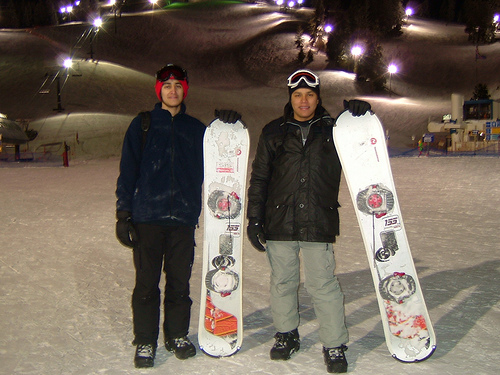Identify and read out the text in this image. 155 